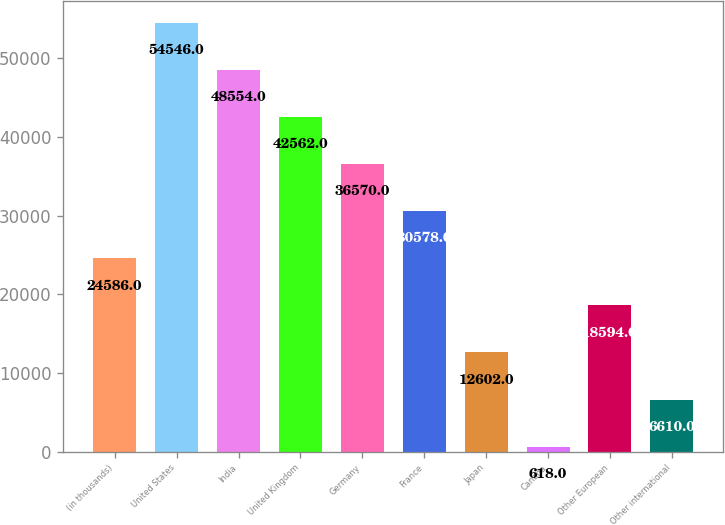Convert chart to OTSL. <chart><loc_0><loc_0><loc_500><loc_500><bar_chart><fcel>(in thousands)<fcel>United States<fcel>India<fcel>United Kingdom<fcel>Germany<fcel>France<fcel>Japan<fcel>Canada<fcel>Other European<fcel>Other international<nl><fcel>24586<fcel>54546<fcel>48554<fcel>42562<fcel>36570<fcel>30578<fcel>12602<fcel>618<fcel>18594<fcel>6610<nl></chart> 